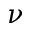Convert formula to latex. <formula><loc_0><loc_0><loc_500><loc_500>\nu</formula> 